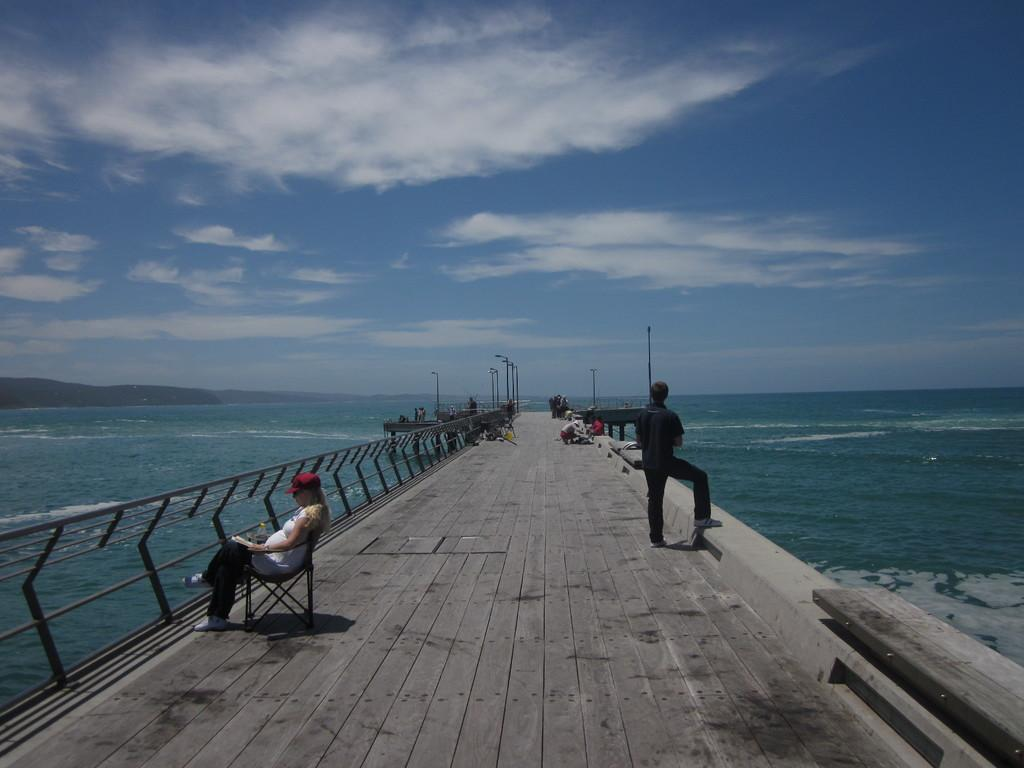What can be seen on the bridge in the image? There are persons on the bridge in the image. What is located in the middle of the image? There is a sea in the middle of the image. What is visible in the background of the image? There is a sky visible in the background of the image. What songs are being sung by the persons on the bridge? There is no mention of songs being sung by the persons on the bridge in the image. What birthday is being celebrated on the bridge? There is no mention of a birthday being celebrated on the bridge in the image. 